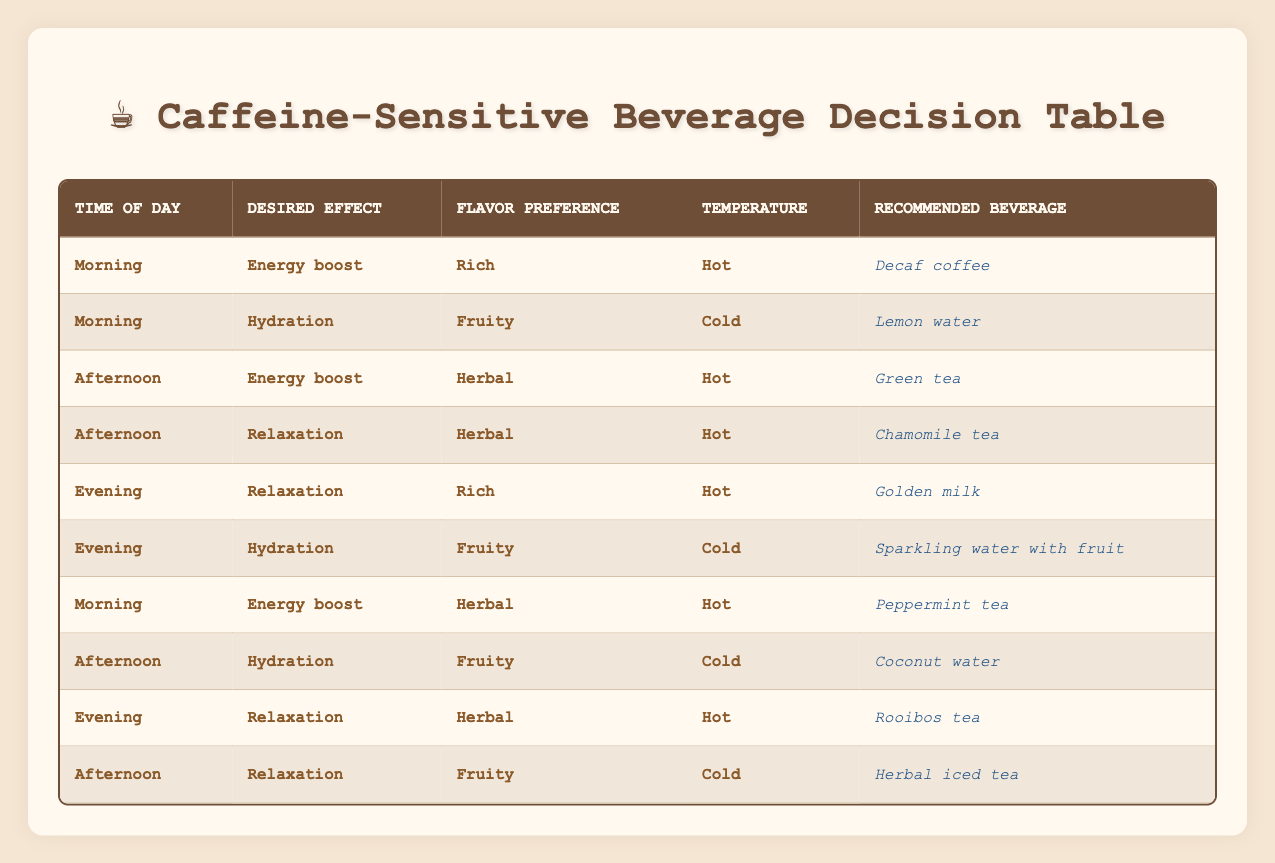What is the recommended beverage in the morning for an energy boost and rich flavor? According to the table, the conditions for the morning, energy boost, and rich flavor are met by the beverage listed in the corresponding row. The recommended beverage is Decaf coffee.
Answer: Decaf coffee Which beverage is suggested for afternoon hydration with a fruity flavor? The table specifies that in the afternoon, when the desired effect is hydration and the flavor preference is fruity, the recommended beverage is Coconut water.
Answer: Coconut water Is Green tea recommended in the evening? The table shows that Green tea is listed under the conditions for afternoon energy boost and herbal flavor. Therefore, it is not recommended for the evening.
Answer: No How many different beverage options are recommended in the evening? By reviewing the table for the evening conditions, we find four different beverages: Golden milk, Sparkling water with fruit, Rooibos tea, and one other not specified here. Therefore, there are four options in total.
Answer: Four What is the recommended beverage for morning relaxation with an herbal flavor? The table does not list a recommended beverage for morning relaxation when the flavor preference is herbal; thus, it concludes that there is none in this specific instance.
Answer: None Which drink is recommended for evening relaxation with a rich flavor? Referring to the table, the conditions for evening, relaxation, and rich flavor correspond to Golden milk, making it the recommended beverage for these parameters.
Answer: Golden milk If a person wants a fruity, cold drink in the afternoon, what is the recommended beverage? The table indicates that in the afternoon, the desired effect is hydration with a fruity flavor, and the recommended beverage is Coconut water.
Answer: Coconut water How does the number of cold drinks compare to hot drinks in the afternoon? In the afternoon, there are two drinks listed: Green tea (hot) for energy boost and Chamomile tea (hot) for relaxation, and Herbal iced tea (cold) along with Coconut water (cold) for hydration. This leads to three hot drinks and two cold drinks; therefore, there are more hot drinks than cold.
Answer: More hot drinks What is the recommended beverage if you want an herbal flavor in the evening? Looking at the evening conditions with an herbal flavor, the table specifies Rooibos tea as the recommended beverage for evening relaxation.
Answer: Rooibos tea 